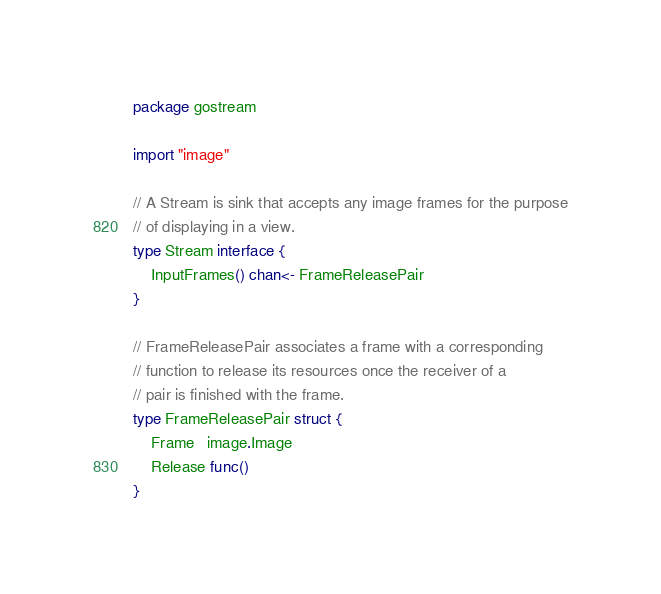<code> <loc_0><loc_0><loc_500><loc_500><_Go_>package gostream

import "image"

// A Stream is sink that accepts any image frames for the purpose
// of displaying in a view.
type Stream interface {
	InputFrames() chan<- FrameReleasePair
}

// FrameReleasePair associates a frame with a corresponding
// function to release its resources once the receiver of a
// pair is finished with the frame.
type FrameReleasePair struct {
	Frame   image.Image
	Release func()
}
</code> 